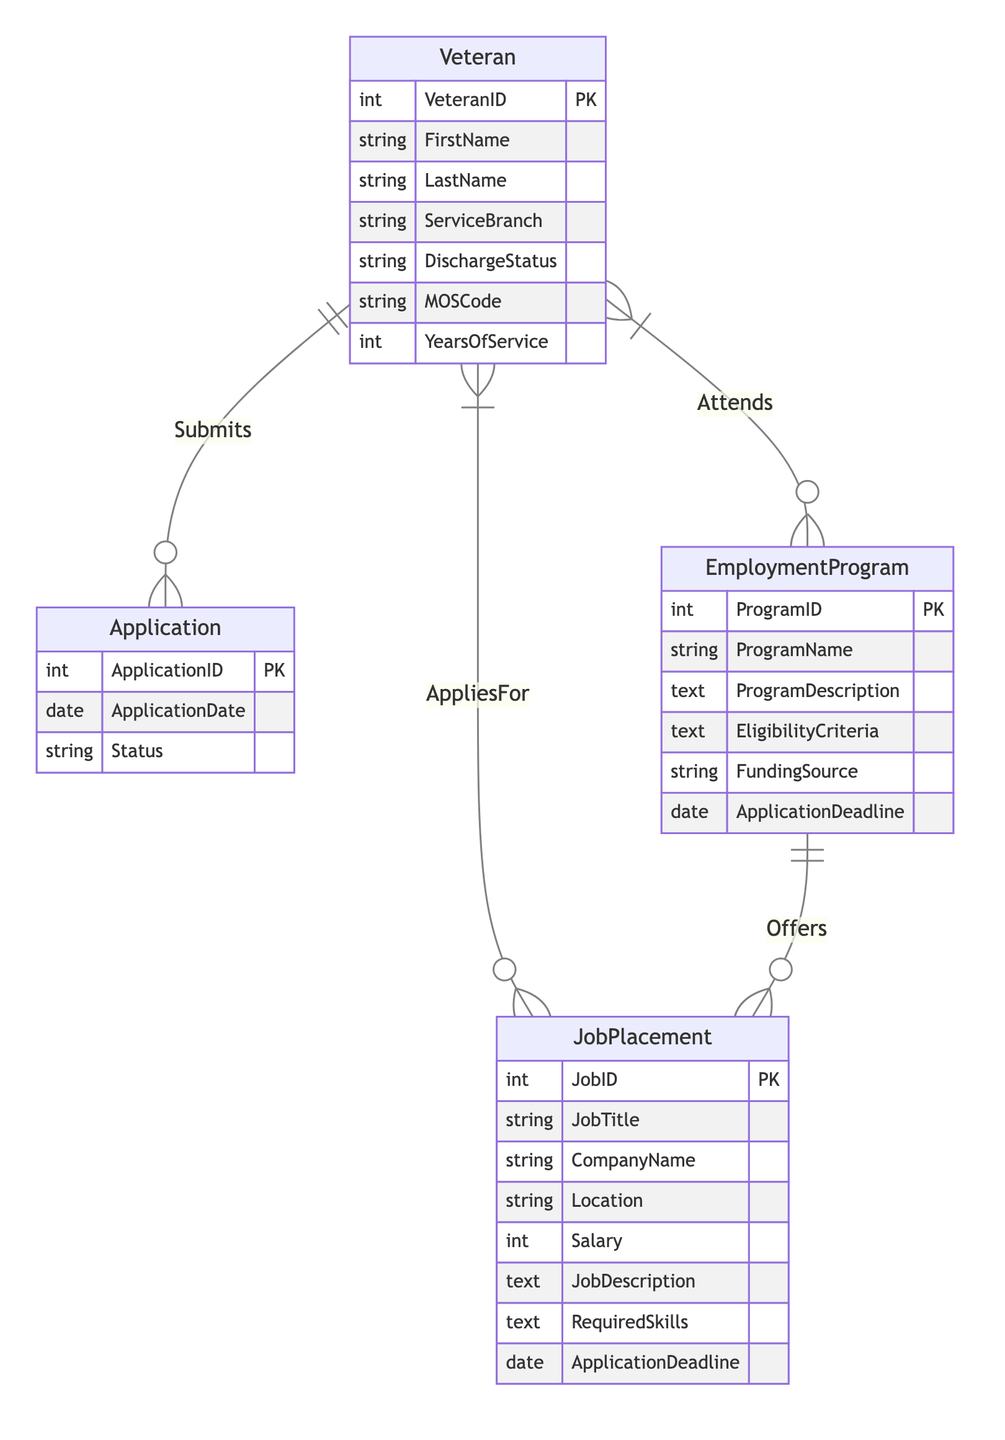What entities are present in the diagram? The diagram lists four entities: Veteran, EmploymentProgram, JobPlacement, and Application.
Answer: Veteran, EmploymentProgram, JobPlacement, Application How many attributes does the Veteran entity have? The Veteran entity consists of seven attributes: VeteranID, FirstName, LastName, ServiceBranch, DischargeStatus, MOSCode, and YearsOfService.
Answer: Seven What is the relationship between Veteran and EmploymentProgram? The relationship between Veteran and EmploymentProgram is labeled as "Attends", which indicates a Many-to-Many connection between these two entities.
Answer: Attends How many application statuses can a veteran have? The Application entity has one attribute for status, meaning each application can have a single status.
Answer: One What is the primary key of the JobPlacement entity? The primary key of the JobPlacement entity is JobID, which uniquely identifies each job placement in the system.
Answer: JobID How many relationships are present in the diagram? The diagram illustrates four relationships: Submits, Attends, AppliesFor, and Offers.
Answer: Four What type of relationship exists between EmploymentProgram and JobPlacement? The relationship between EmploymentProgram and JobPlacement is a One-to-Many relationship, indicating that one program can offer multiple job placements.
Answer: One-to-Many What foreign key is associated with the AppliesFor relationship? The foreign key associated with the AppliesFor relationship is ApplicationID, which connects the Veteran entity to their job applications.
Answer: ApplicationID Which entity has a relationship with both EmploymentProgram and JobPlacement? The Veteran entity has relationships with both EmploymentProgram (Attends) and JobPlacement (AppliesFor).
Answer: Veteran 